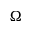Convert formula to latex. <formula><loc_0><loc_0><loc_500><loc_500>\Omega</formula> 